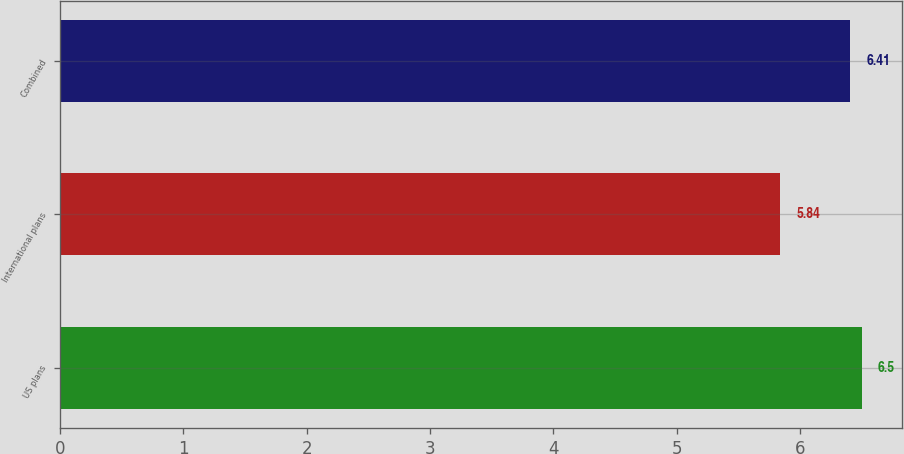<chart> <loc_0><loc_0><loc_500><loc_500><bar_chart><fcel>US plans<fcel>International plans<fcel>Combined<nl><fcel>6.5<fcel>5.84<fcel>6.41<nl></chart> 